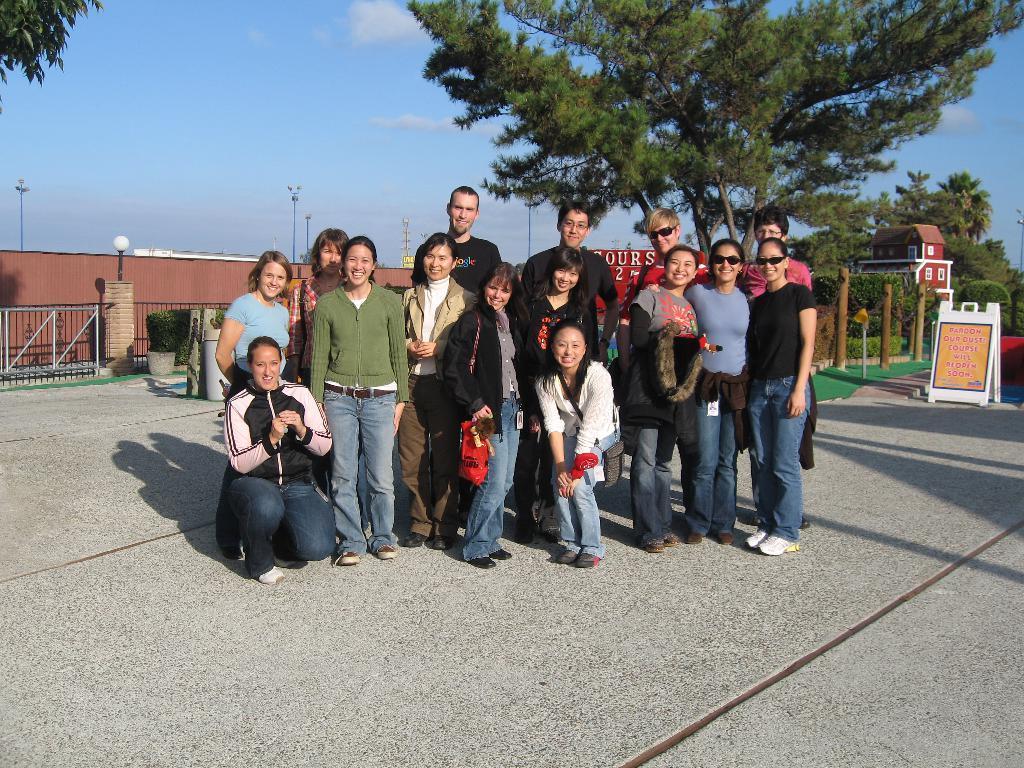Describe this image in one or two sentences. This is an outside view. Here I can see a crowd of people standing on the road, smiling and giving pose for the picture. In the background, I can see many trees, building and poles. On the right side I can see a board which is placed on the road. On the board, I can see some text. On the left side, I can see the railing and house plant which is placed on the floor. At the top of the image I can see the sky. 